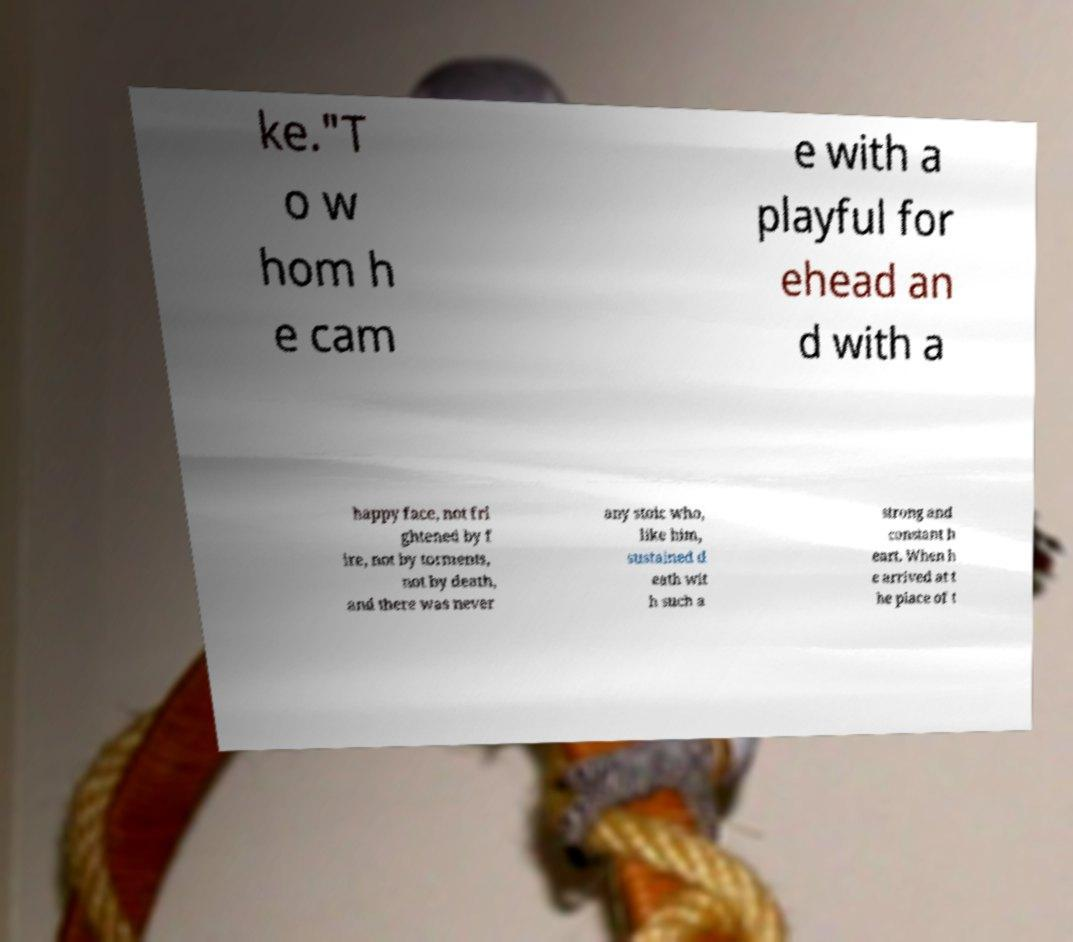Please read and relay the text visible in this image. What does it say? ke."T o w hom h e cam e with a playful for ehead an d with a happy face, not fri ghtened by f ire, not by torments, not by death, and there was never any stoic who, like him, sustained d eath wit h such a strong and constant h eart. When h e arrived at t he place of t 